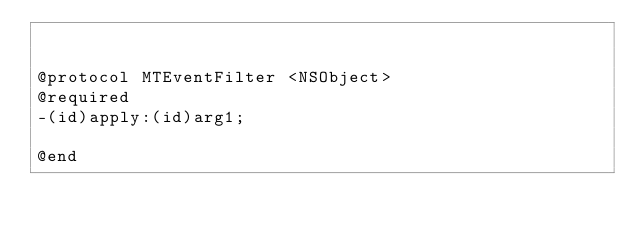Convert code to text. <code><loc_0><loc_0><loc_500><loc_500><_C_>

@protocol MTEventFilter <NSObject>
@required
-(id)apply:(id)arg1;

@end

</code> 